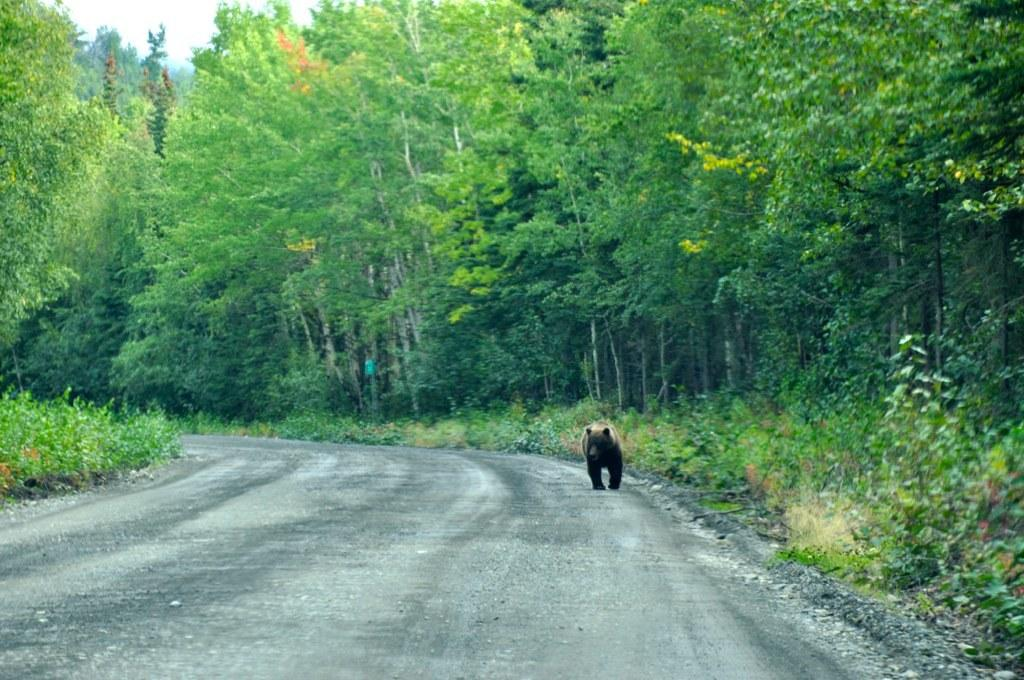What animal is present in the image? There is a bear in the image. Where is the bear located in the image? The bear is standing on the road. What can be seen in the background of the image? There are trees on either side of the road. What story is the bear telling to the passengers in the image? There are no passengers present in the image, and the bear is not telling a story. 